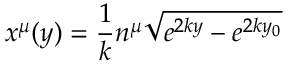<formula> <loc_0><loc_0><loc_500><loc_500>x ^ { \mu } ( y ) = { \frac { 1 } { k } } n ^ { \mu } \sqrt { e ^ { 2 k y } - e ^ { 2 k y _ { 0 } } }</formula> 